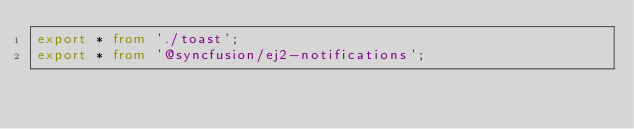<code> <loc_0><loc_0><loc_500><loc_500><_TypeScript_>export * from './toast';
export * from '@syncfusion/ej2-notifications';</code> 